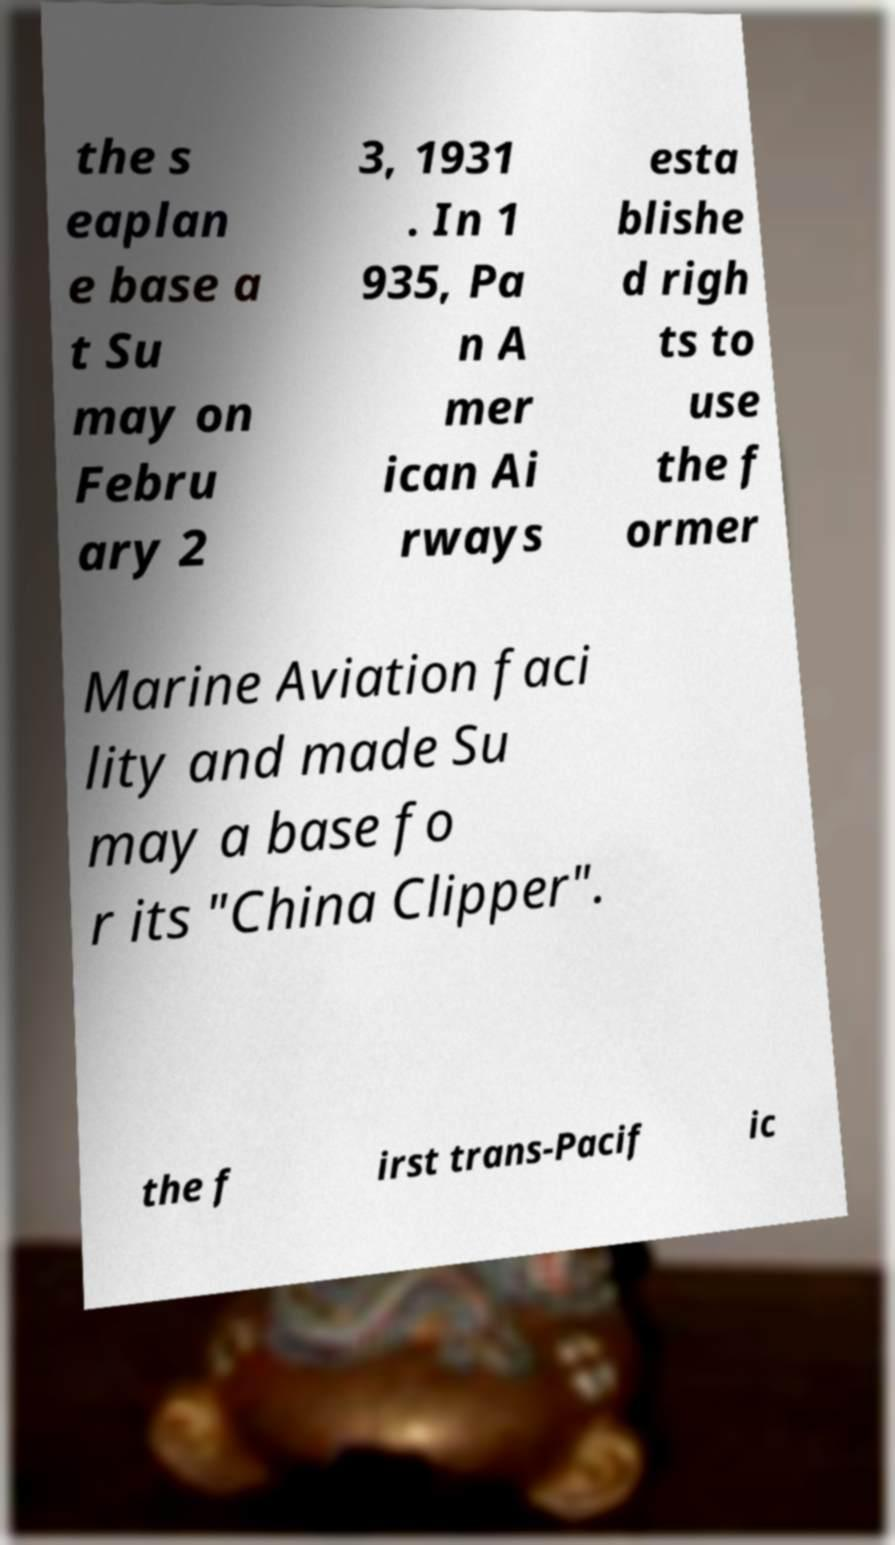For documentation purposes, I need the text within this image transcribed. Could you provide that? the s eaplan e base a t Su may on Febru ary 2 3, 1931 . In 1 935, Pa n A mer ican Ai rways esta blishe d righ ts to use the f ormer Marine Aviation faci lity and made Su may a base fo r its "China Clipper". the f irst trans-Pacif ic 